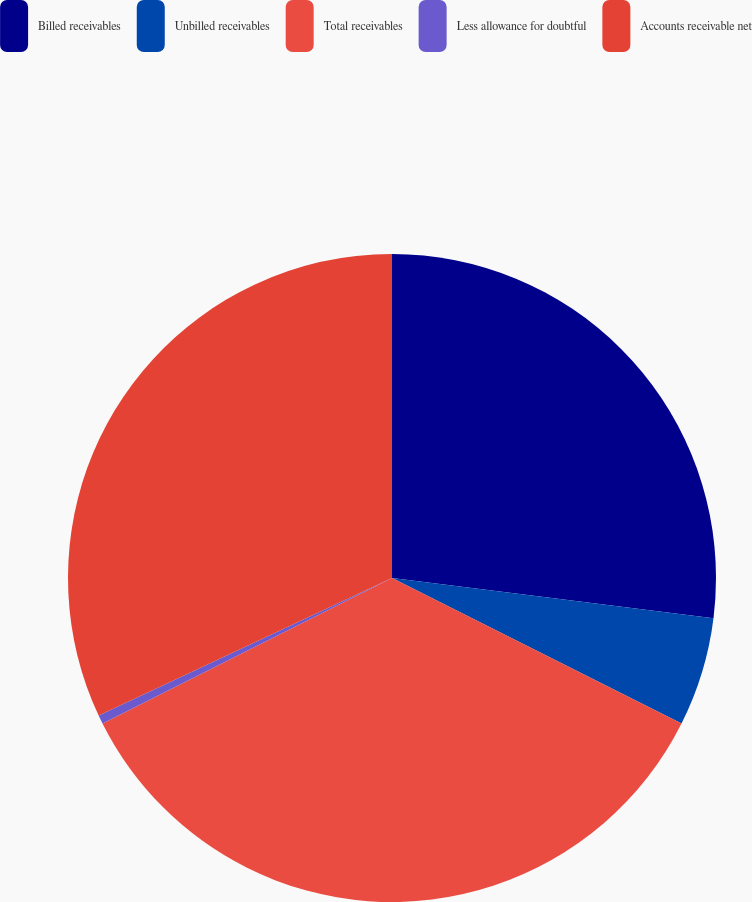<chart> <loc_0><loc_0><loc_500><loc_500><pie_chart><fcel>Billed receivables<fcel>Unbilled receivables<fcel>Total receivables<fcel>Less allowance for doubtful<fcel>Accounts receivable net<nl><fcel>26.98%<fcel>5.43%<fcel>35.18%<fcel>0.43%<fcel>31.98%<nl></chart> 